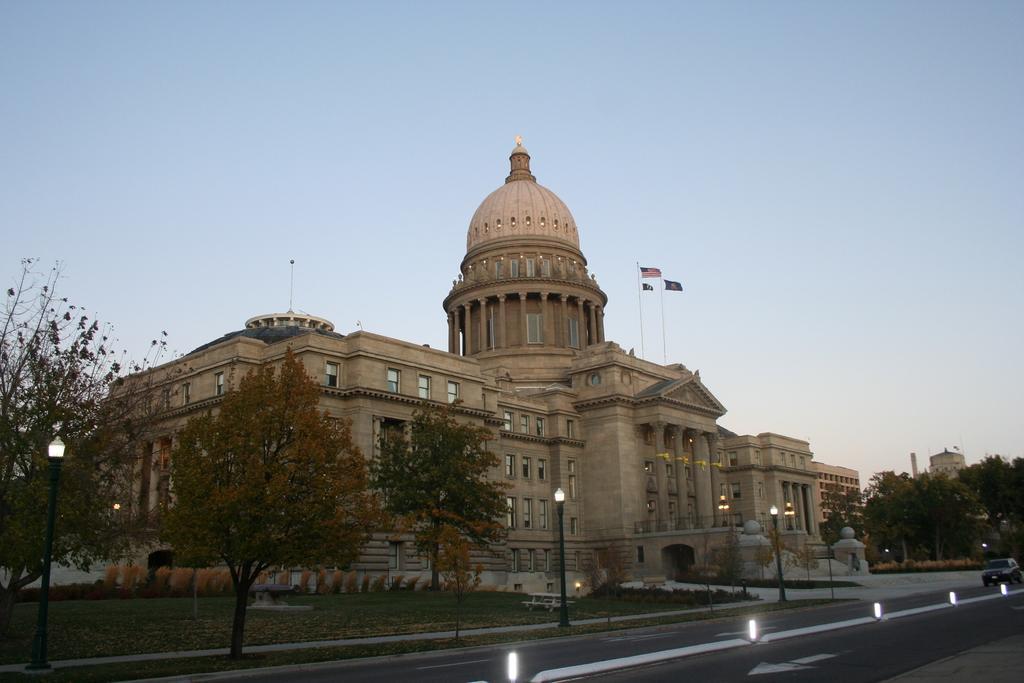Describe this image in one or two sentences. In this picture I can see the monument. In front of the dome I can see the flags. At the bottom I can see the cars, road, street lights, trees, plants and grass. In the background I can see the buildings. At the top I can see the sky. 